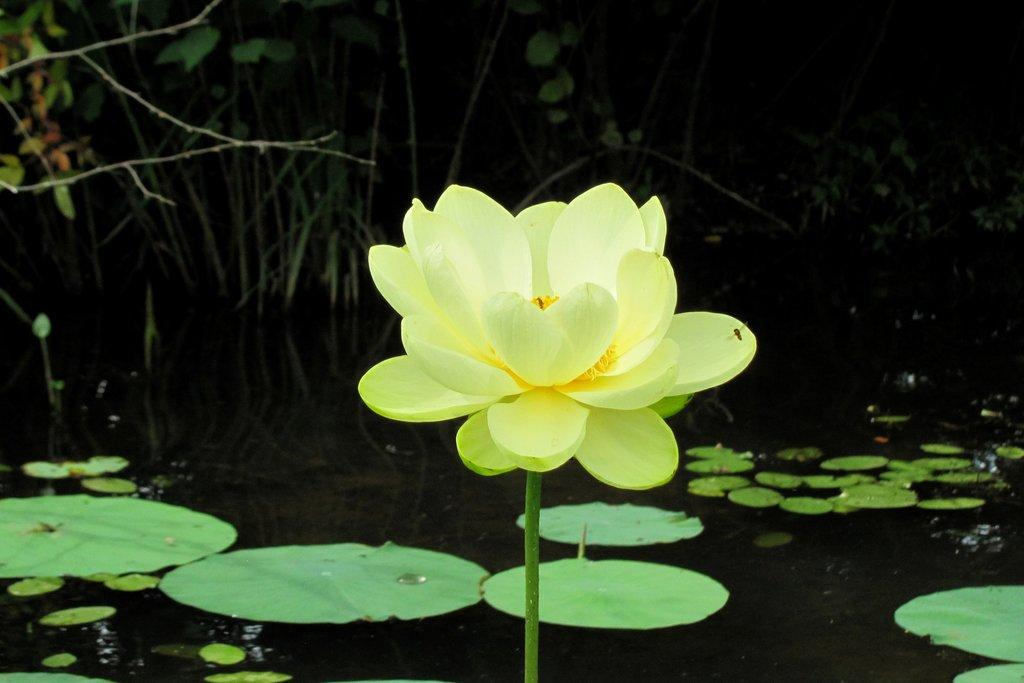What type of flower is in the image? There is a beautiful lotus flower in the image. What color is the lotus flower? The lotus flower is yellow in color. What else can be seen in the water in the image? There are lotus leaves in the water in the image. How many fish can be seen jumping out of the water in the image? There are no fish present in the image, and therefore no fish can be seen jumping out of the water. 